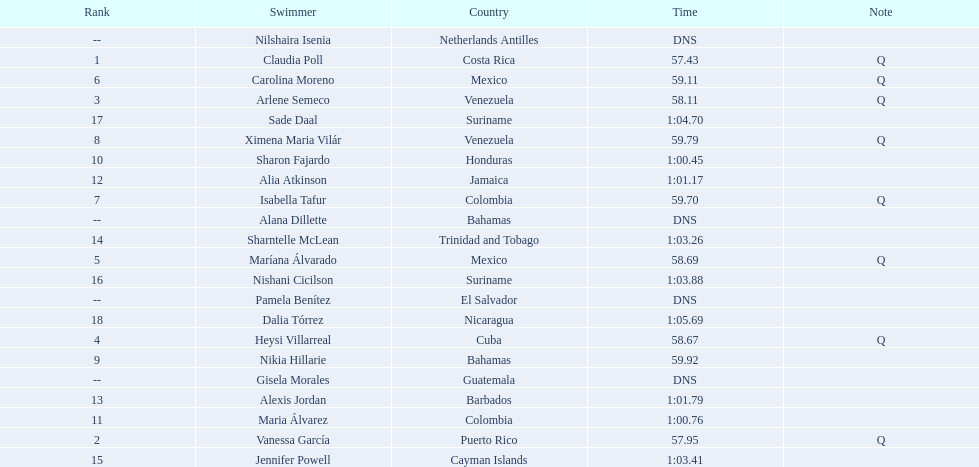Where were the top eight finishers from? Costa Rica, Puerto Rico, Venezuela, Cuba, Mexico, Mexico, Colombia, Venezuela. Which of the top eight were from cuba? Heysi Villarreal. 